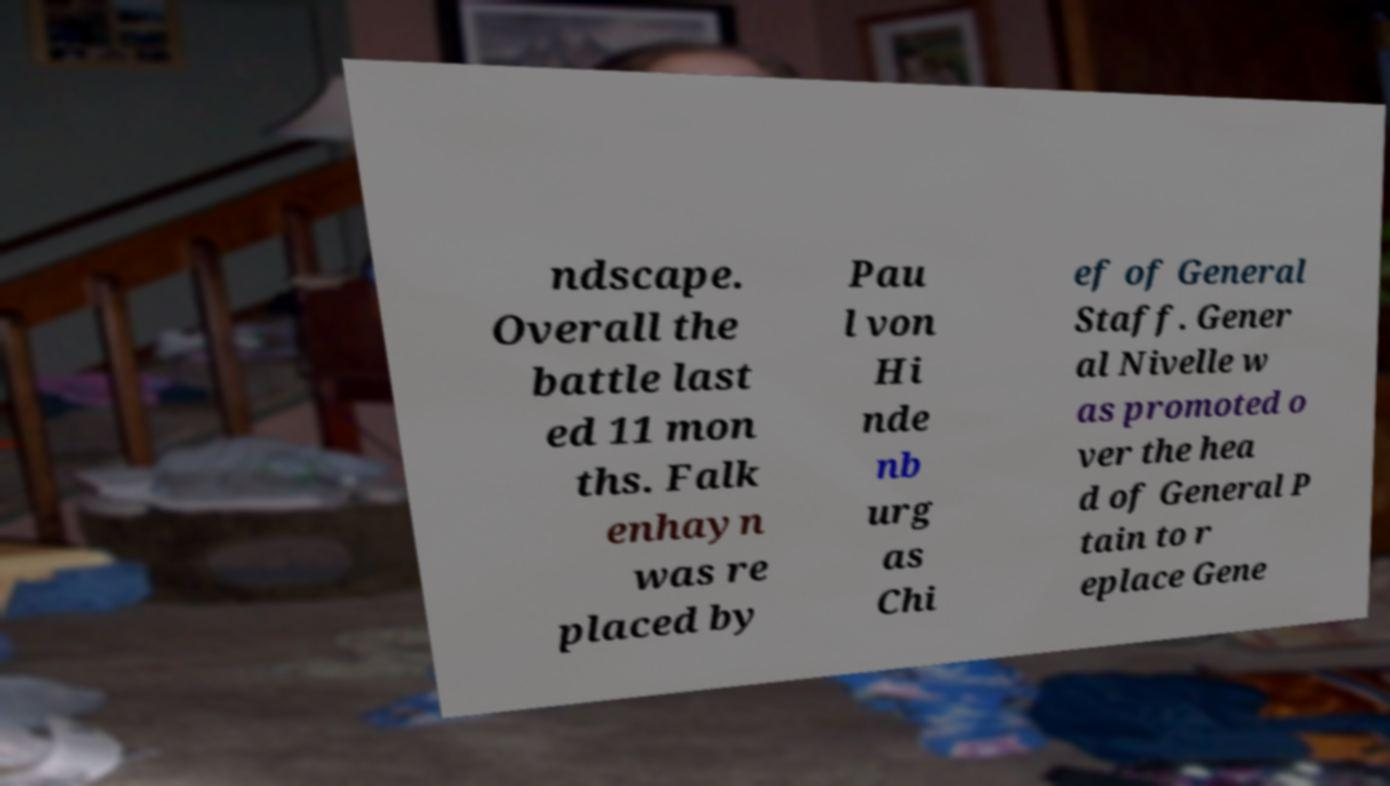For documentation purposes, I need the text within this image transcribed. Could you provide that? ndscape. Overall the battle last ed 11 mon ths. Falk enhayn was re placed by Pau l von Hi nde nb urg as Chi ef of General Staff. Gener al Nivelle w as promoted o ver the hea d of General P tain to r eplace Gene 